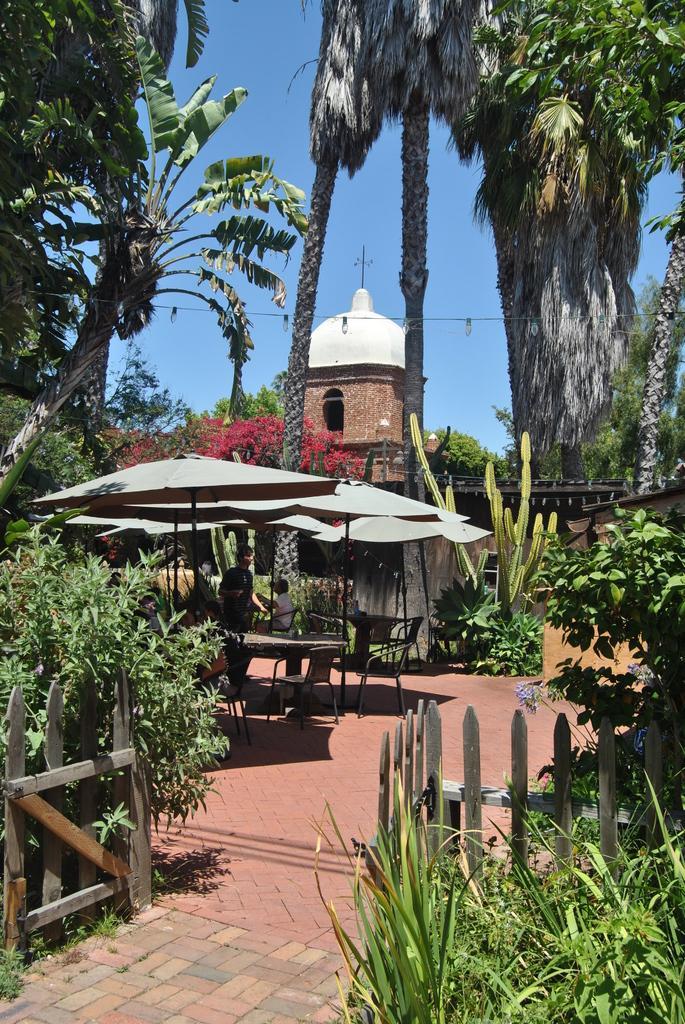In one or two sentences, can you explain what this image depicts? In this image I can see plants, number of trees, white colour shades, shadows, chairs, a table and I can see few people. In the background I can see a building and the sky. 